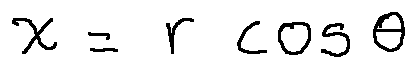<formula> <loc_0><loc_0><loc_500><loc_500>x = r \cos \theta</formula> 